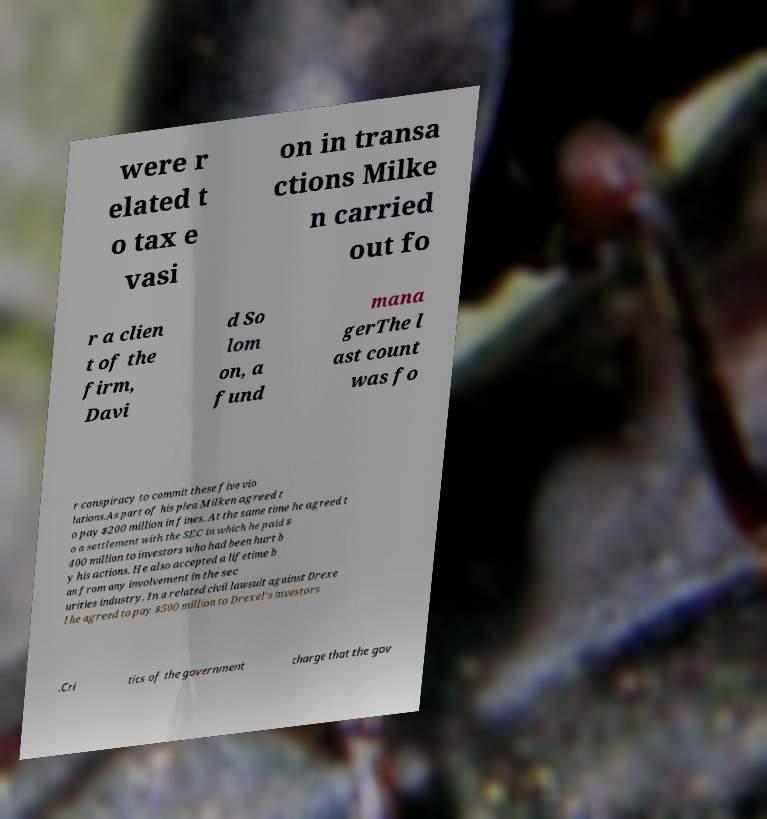Could you extract and type out the text from this image? were r elated t o tax e vasi on in transa ctions Milke n carried out fo r a clien t of the firm, Davi d So lom on, a fund mana gerThe l ast count was fo r conspiracy to commit these five vio lations.As part of his plea Milken agreed t o pay $200 million in fines. At the same time he agreed t o a settlement with the SEC in which he paid $ 400 million to investors who had been hurt b y his actions. He also accepted a lifetime b an from any involvement in the sec urities industry. In a related civil lawsuit against Drexe l he agreed to pay $500 million to Drexel's investors .Cri tics of the government charge that the gov 